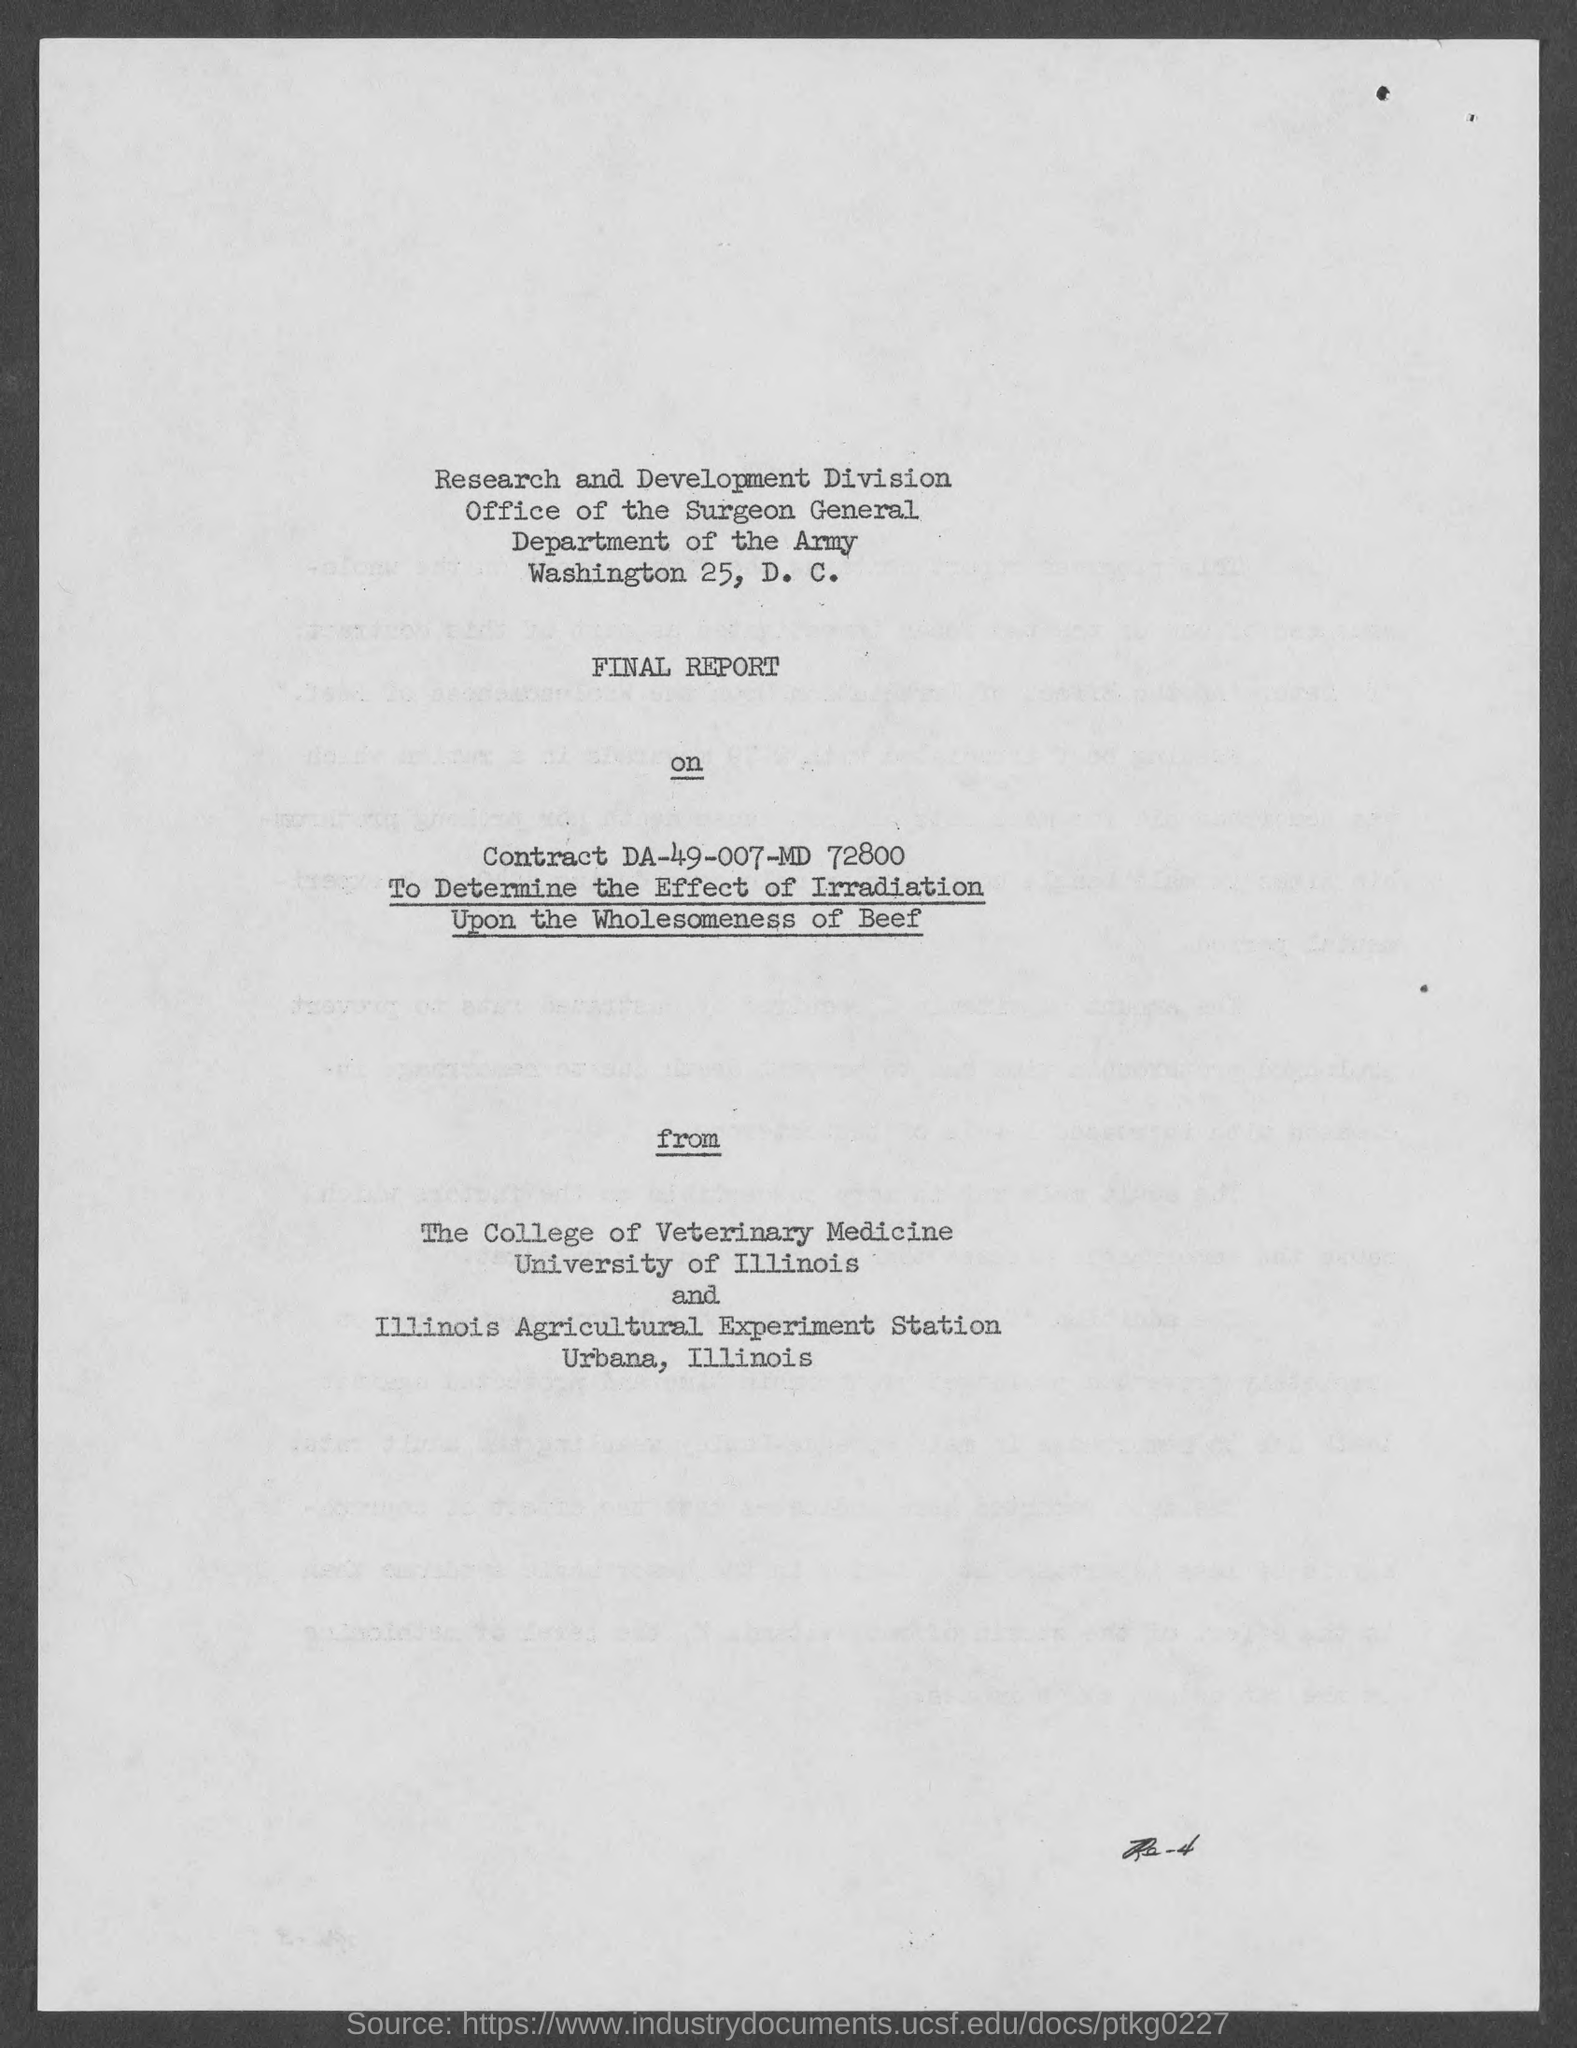What is the department?
Keep it short and to the point. Department of the Army. What is the report about?
Provide a short and direct response. To Determine the Effect of Irradiation Upon the Wholesomeness of Beef. What is Contract No.?
Offer a very short reply. DA-49-007-MD 72800. 